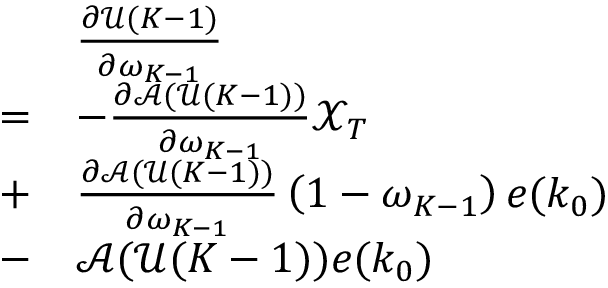Convert formula to latex. <formula><loc_0><loc_0><loc_500><loc_500>\begin{array} { r l } & { \frac { \partial \ m a t h s c r { U } ( K - 1 ) } { \partial \omega _ { K - 1 } } } \\ { = } & { - \frac { \partial \ m a t h s c r { A } ( \ m a t h s c r { U } ( K - 1 ) ) } { \partial \omega _ { K - 1 } } \ m a t h s c r { X } _ { T } } \\ { + } & { \frac { \partial \ m a t h s c r { A } ( \ m a t h s c r { U } ( K - 1 ) ) } { \partial \omega _ { K - 1 } } \left ( 1 - \omega _ { K - 1 } \right ) e ( k _ { 0 } ) } \\ { - } & { \ m a t h s c r { A } ( \ m a t h s c r { U } ( K - 1 ) ) e ( k _ { 0 } ) } \end{array}</formula> 